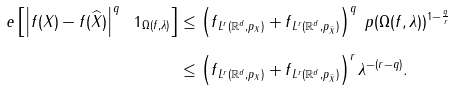Convert formula to latex. <formula><loc_0><loc_0><loc_500><loc_500>\ e \left [ \left | f ( X ) - f ( \widehat { X } ) \right | ^ { q } \ 1 _ { \Omega ( f , \lambda ) } \right ] & \leq \left ( \| f \| _ { L ^ { r } ( { \mathbb { R } } ^ { d } , p _ { X } ) } + \| f \| _ { L ^ { r } ( { \mathbb { R } } ^ { d } , p _ { \widehat { X } } ) } \right ) ^ { q } \ p ( \Omega ( f , \lambda ) ) ^ { 1 - \frac { q } { r } } \\ & \leq \left ( \| f \| _ { L ^ { r } ( { \mathbb { R } } ^ { d } , p _ { X } ) } + \| f \| _ { L ^ { r } ( { \mathbb { R } } ^ { d } , p _ { \widehat { X } } ) } \right ) ^ { r } \lambda ^ { - ( r - q ) } .</formula> 